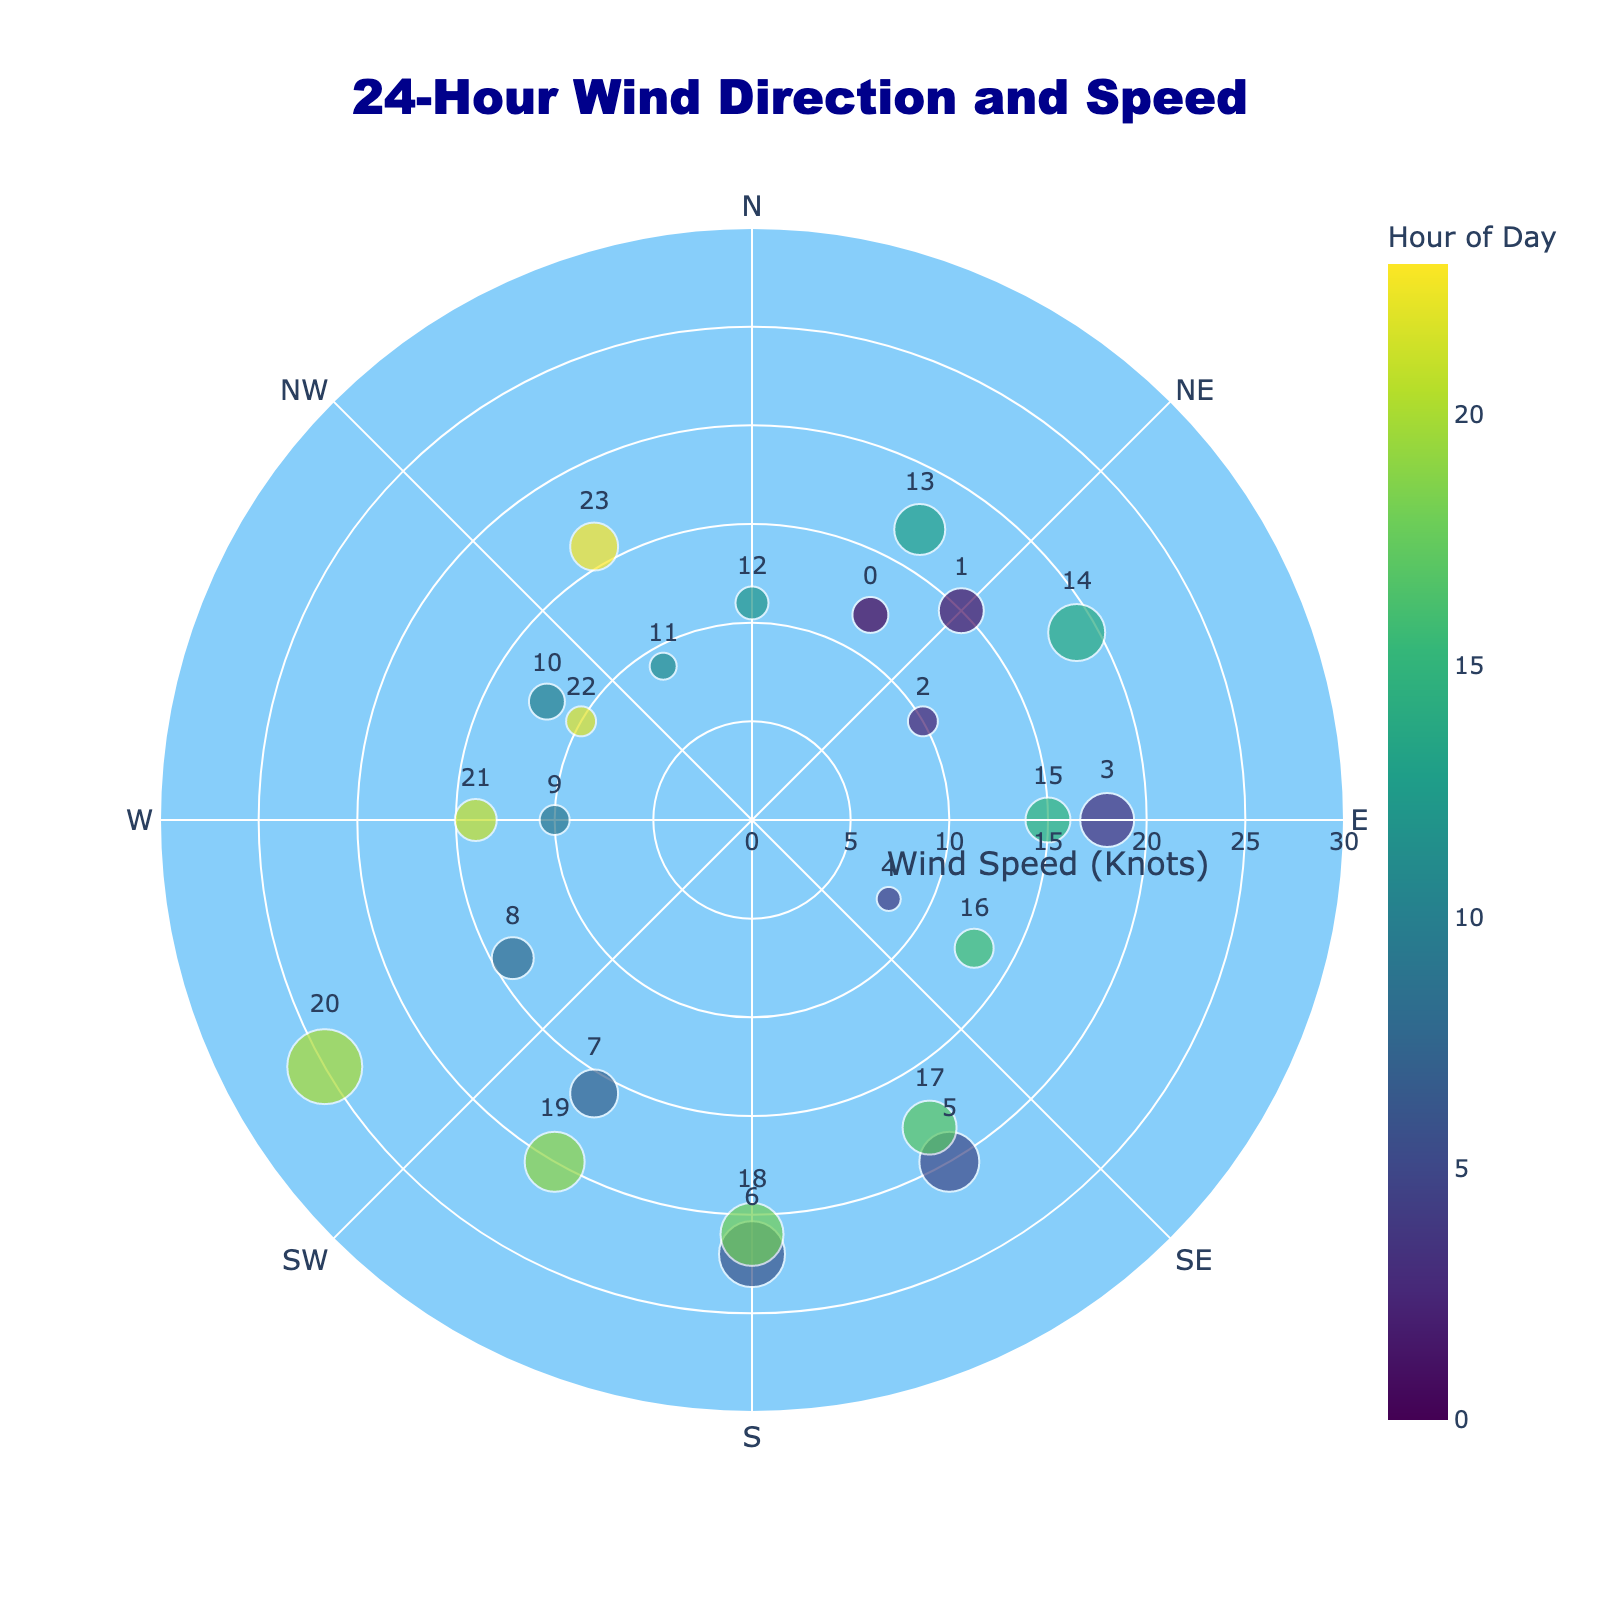What is the title of the figure? The title is found at the top of the figure, typically in bold or larger font. It gives a brief description of what the figure represents.
Answer: 24-Hour Wind Direction and Speed What is the range of wind speeds shown on the radial axis? The radial axis represents wind speed, and the range is indicated from the center outward in defined intervals, along the radial direction. The maximum value is the highest wind speed plus a buffer.
Answer: 0 to 30 knots How many data points represent wind speed at exactly 15 knots? To find this, look at the radial position of the markers and identify those that align with 15 knots. There are markers at 01:00 and 15:00 hours.
Answer: 2 Which hour recorded the highest wind speed and what was the speed? Identify the data point farthest from the center (highest radial value), then check the hovertext or marker size. This is also facilitated by checking color intensity and text labels if available.
Answer: 20:00 recorded 25 knots What direction corresponds to the wind speed recorded at 06:00? Refer to the hovertext or directly to the text labels near the markers to find the hour, then trace the respective angular position.
Answer: South (180°) Which hour experienced the calmest wind and what was the speed? Locate the data point closest to the center (lowest radial value) and check the hovertext or marker size for wind speed information. This point should have the lowest wind speed.
Answer: 04:00 with 8 knots How does the wind direction at 08:00 compare to that at 16:00? Compare the angular positions of markers for the two hours, indicated either by their position or through hovertext.
Answer: 08:00 is at 240° (WSW), 16:00 is at 120° (ESE) What's the average wind speed recorded between 00:00 and 12:00? Note down the wind speeds from 00:00 to 12:00 hours, sum them and divide by the number of hours (13). [(12+15+10+18+8+20+22+16+14+10+12+9+11)/13].
Answer: 13.15 knots What wind direction corresponds to the direction labeled 'N'? The wind directions are labeled around the plot at specific intervals. 'N' stands for North, which is directly upward or 0°.
Answer: 0° At what hours did the wind blow from the southwest (SW) direction? South-West direction corresponds to 225°. Check the angular position for markers closest to this direction by either markers or hovertext.
Answer: None 